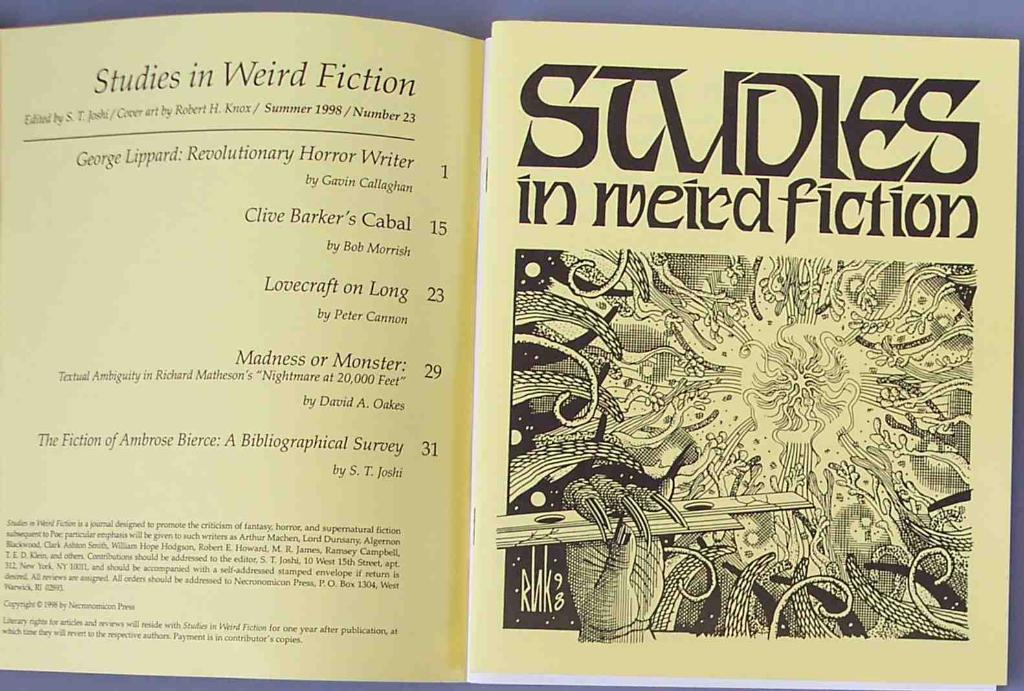<image>
Offer a succinct explanation of the picture presented. The book shown is about studies in weird fiction. 